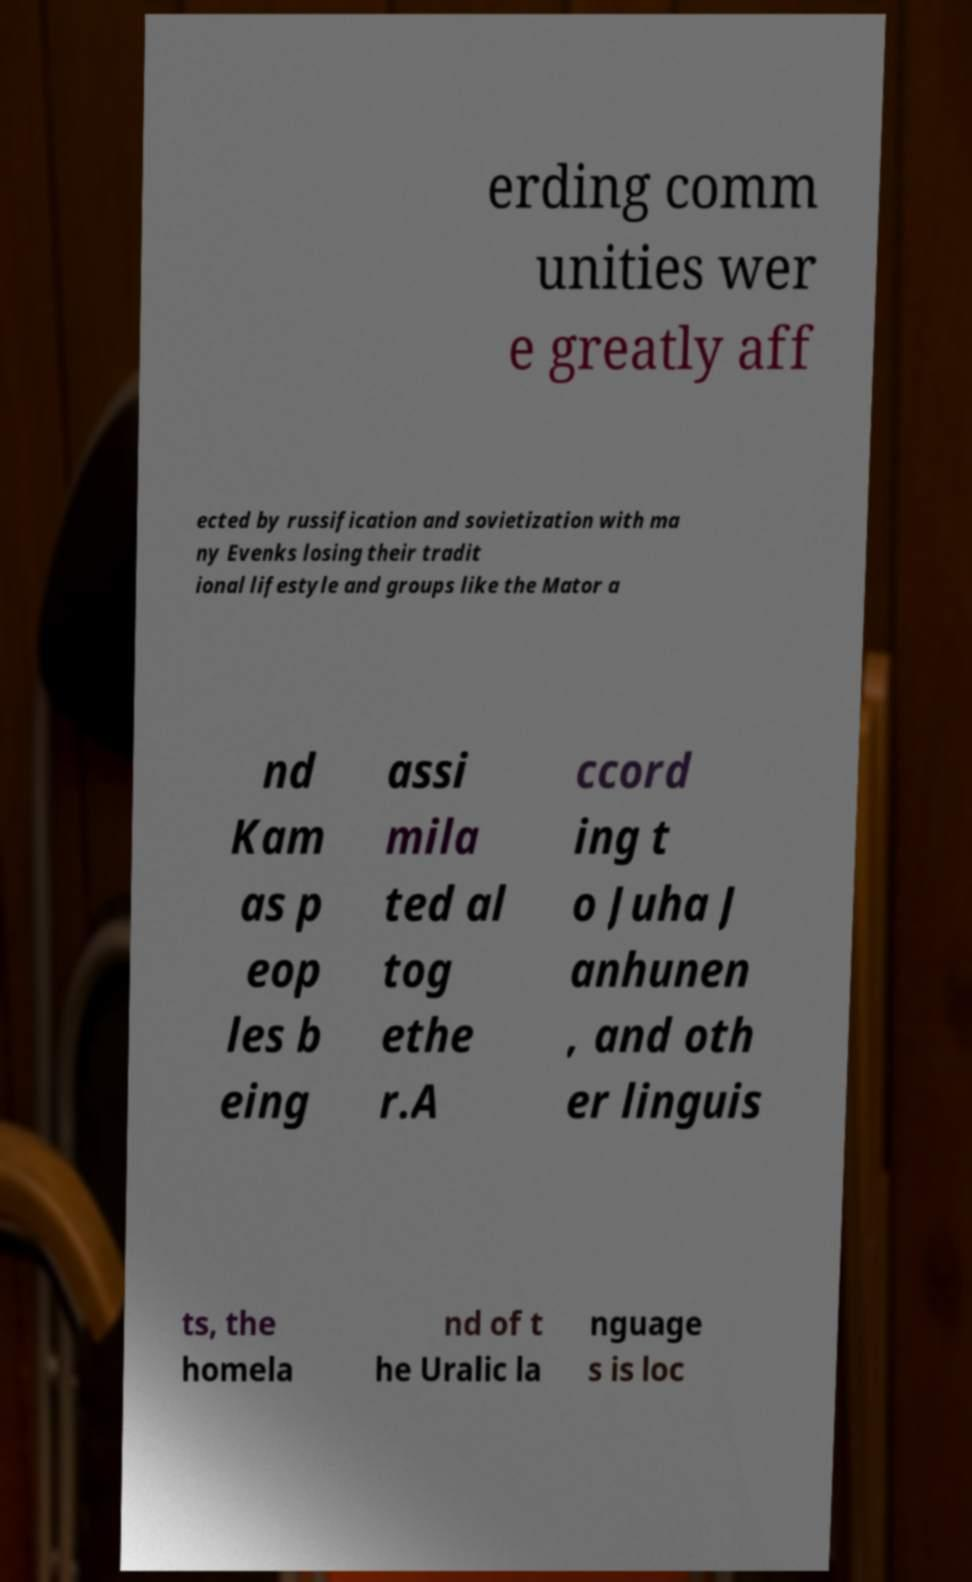Can you read and provide the text displayed in the image?This photo seems to have some interesting text. Can you extract and type it out for me? erding comm unities wer e greatly aff ected by russification and sovietization with ma ny Evenks losing their tradit ional lifestyle and groups like the Mator a nd Kam as p eop les b eing assi mila ted al tog ethe r.A ccord ing t o Juha J anhunen , and oth er linguis ts, the homela nd of t he Uralic la nguage s is loc 